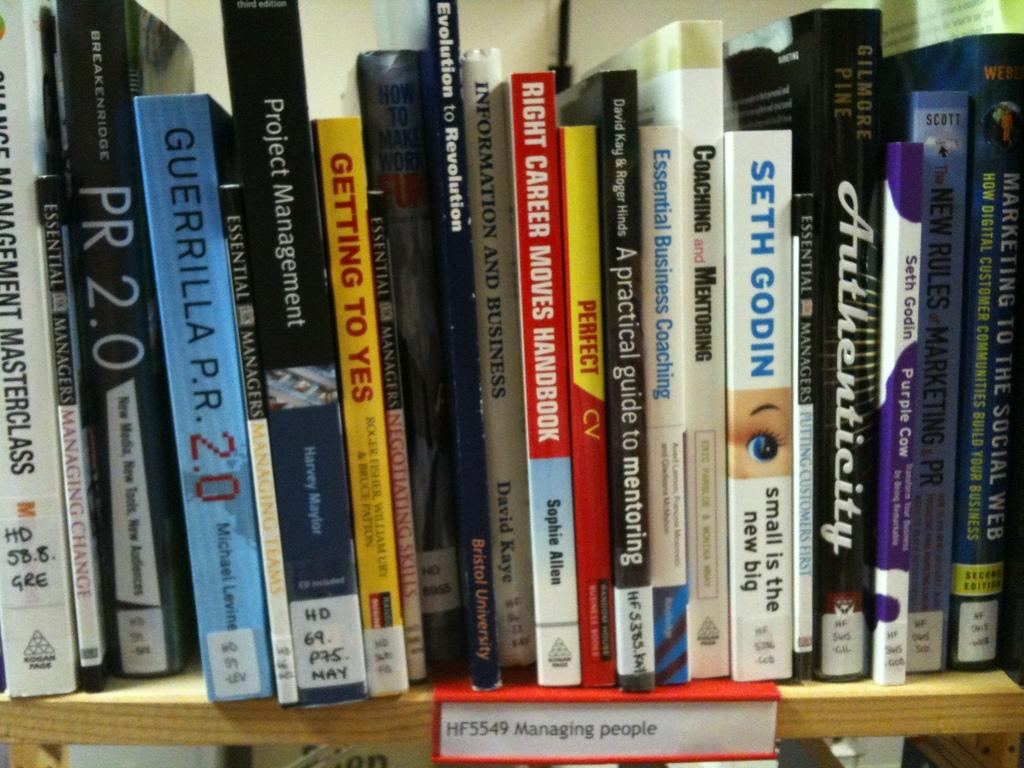<image>
Offer a succinct explanation of the picture presented. The bookshelf is the section to go to if you want to find a book about managing people. 